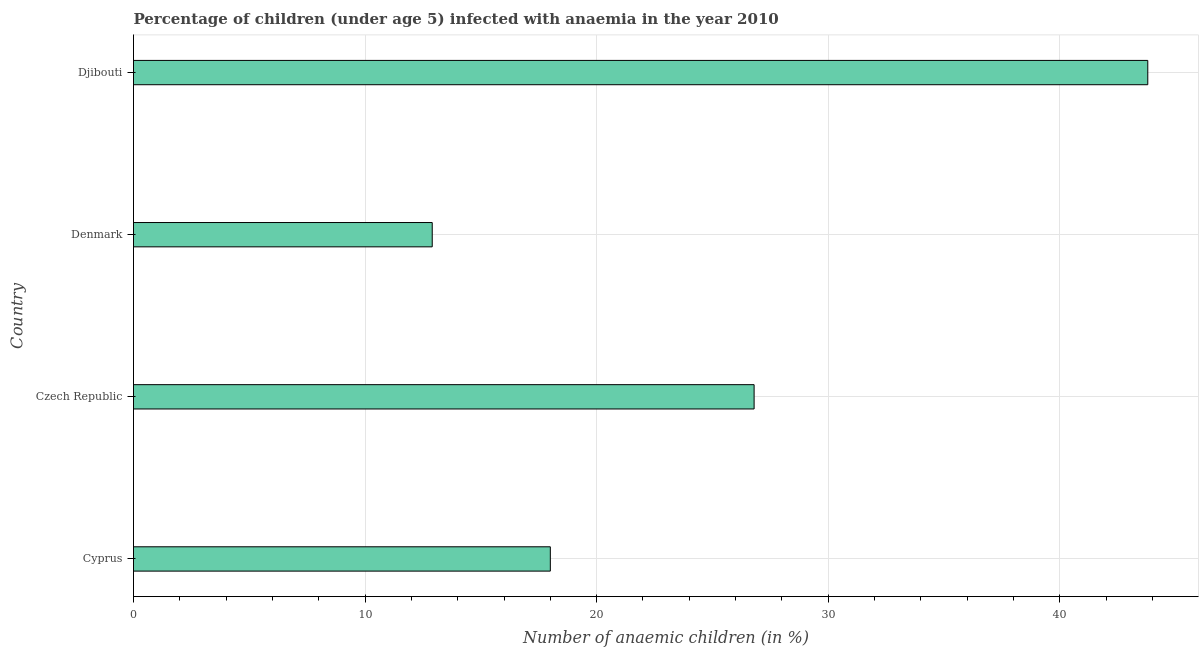Does the graph contain grids?
Keep it short and to the point. Yes. What is the title of the graph?
Make the answer very short. Percentage of children (under age 5) infected with anaemia in the year 2010. What is the label or title of the X-axis?
Ensure brevity in your answer.  Number of anaemic children (in %). What is the number of anaemic children in Denmark?
Keep it short and to the point. 12.9. Across all countries, what is the maximum number of anaemic children?
Keep it short and to the point. 43.8. In which country was the number of anaemic children maximum?
Your answer should be compact. Djibouti. What is the sum of the number of anaemic children?
Provide a short and direct response. 101.5. What is the difference between the number of anaemic children in Denmark and Djibouti?
Your answer should be compact. -30.9. What is the average number of anaemic children per country?
Give a very brief answer. 25.38. What is the median number of anaemic children?
Make the answer very short. 22.4. In how many countries, is the number of anaemic children greater than 36 %?
Your response must be concise. 1. What is the ratio of the number of anaemic children in Denmark to that in Djibouti?
Provide a succinct answer. 0.29. Is the difference between the number of anaemic children in Denmark and Djibouti greater than the difference between any two countries?
Your answer should be very brief. Yes. What is the difference between the highest and the second highest number of anaemic children?
Your answer should be compact. 17. What is the difference between the highest and the lowest number of anaemic children?
Make the answer very short. 30.9. In how many countries, is the number of anaemic children greater than the average number of anaemic children taken over all countries?
Provide a short and direct response. 2. What is the difference between two consecutive major ticks on the X-axis?
Offer a very short reply. 10. What is the Number of anaemic children (in %) of Cyprus?
Ensure brevity in your answer.  18. What is the Number of anaemic children (in %) in Czech Republic?
Keep it short and to the point. 26.8. What is the Number of anaemic children (in %) in Denmark?
Offer a very short reply. 12.9. What is the Number of anaemic children (in %) of Djibouti?
Ensure brevity in your answer.  43.8. What is the difference between the Number of anaemic children (in %) in Cyprus and Czech Republic?
Your answer should be very brief. -8.8. What is the difference between the Number of anaemic children (in %) in Cyprus and Djibouti?
Offer a terse response. -25.8. What is the difference between the Number of anaemic children (in %) in Czech Republic and Denmark?
Keep it short and to the point. 13.9. What is the difference between the Number of anaemic children (in %) in Denmark and Djibouti?
Give a very brief answer. -30.9. What is the ratio of the Number of anaemic children (in %) in Cyprus to that in Czech Republic?
Keep it short and to the point. 0.67. What is the ratio of the Number of anaemic children (in %) in Cyprus to that in Denmark?
Your answer should be compact. 1.4. What is the ratio of the Number of anaemic children (in %) in Cyprus to that in Djibouti?
Give a very brief answer. 0.41. What is the ratio of the Number of anaemic children (in %) in Czech Republic to that in Denmark?
Offer a terse response. 2.08. What is the ratio of the Number of anaemic children (in %) in Czech Republic to that in Djibouti?
Your answer should be compact. 0.61. What is the ratio of the Number of anaemic children (in %) in Denmark to that in Djibouti?
Your answer should be compact. 0.29. 